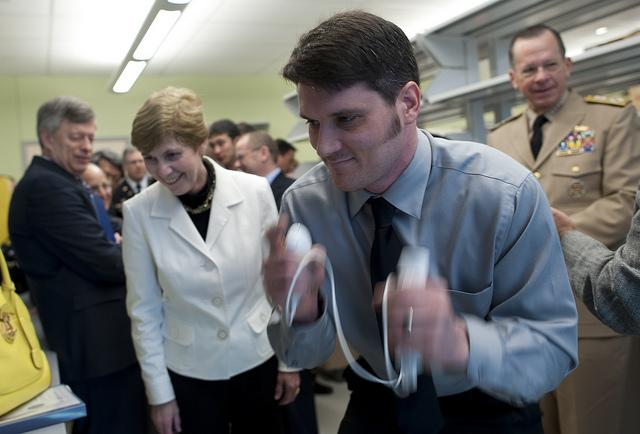What is the hair on the side of the man's cheek called? sideburn 